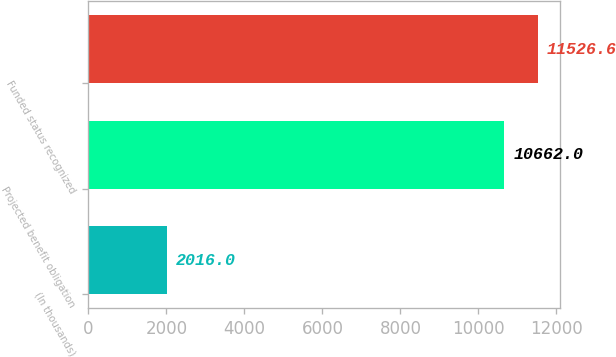Convert chart to OTSL. <chart><loc_0><loc_0><loc_500><loc_500><bar_chart><fcel>(In thousands)<fcel>Projected benefit obligation<fcel>Funded status recognized<nl><fcel>2016<fcel>10662<fcel>11526.6<nl></chart> 